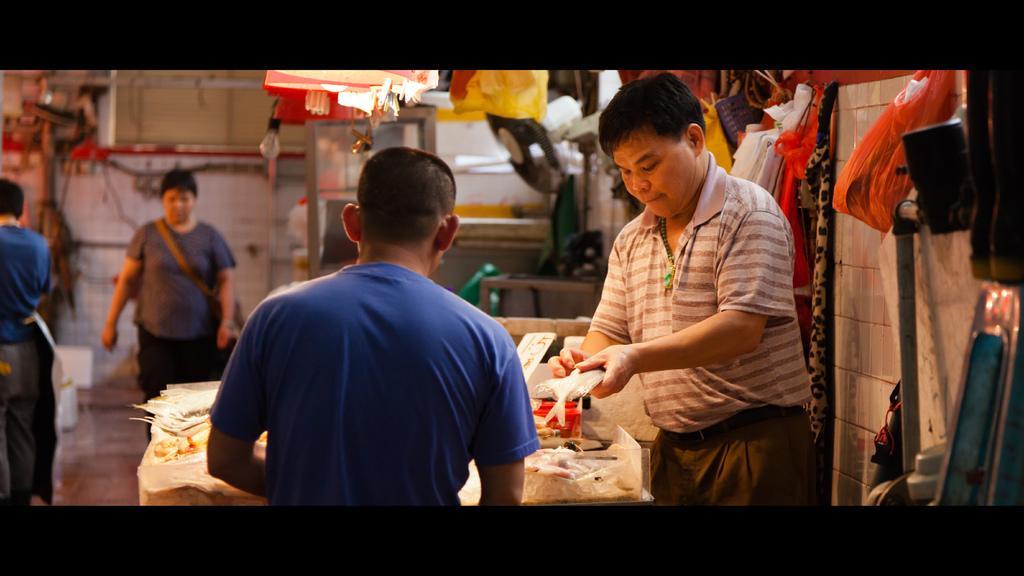Can you describe this image briefly? There is a person holding a fish. In front of him there is another person. There is a table. On that there are many items. In the back there are some people. On the right side there is a wall. On that there are some items kept. In the background there is a bulb and there are many items. 